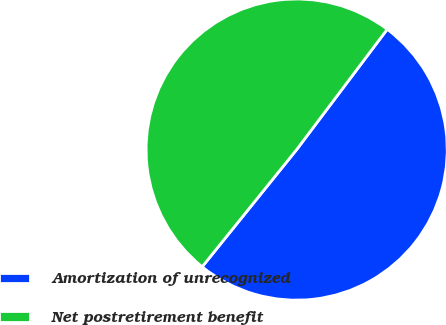<chart> <loc_0><loc_0><loc_500><loc_500><pie_chart><fcel>Amortization of unrecognized<fcel>Net postretirement benefit<nl><fcel>50.53%<fcel>49.47%<nl></chart> 